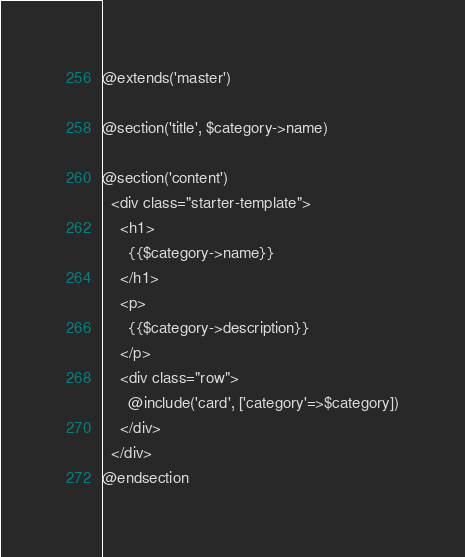<code> <loc_0><loc_0><loc_500><loc_500><_PHP_>@extends('master')

@section('title', $category->name)

@section('content')
  <div class="starter-template">
    <h1>
      {{$category->name}}
    </h1>
    <p>
      {{$category->description}}
    </p>
    <div class="row">
      @include('card', ['category'=>$category])
    </div>
  </div>
@endsection
</code> 